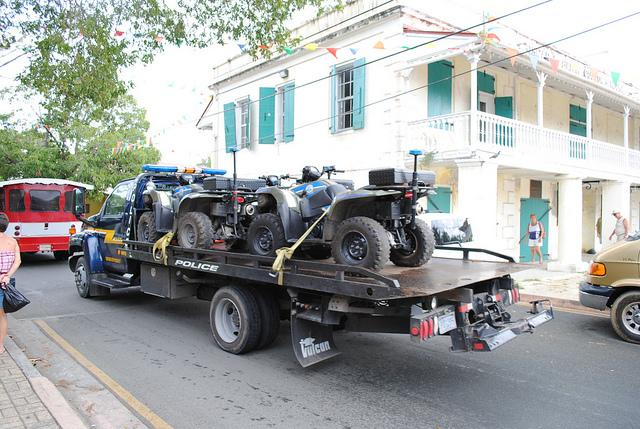The ATVs being carried on the flatbed truck are used by which public agency?

Choices:
A) fire department
B) police
C) city hall
D) health department police 